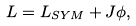<formula> <loc_0><loc_0><loc_500><loc_500>L = L _ { S Y M } + J \phi ,</formula> 